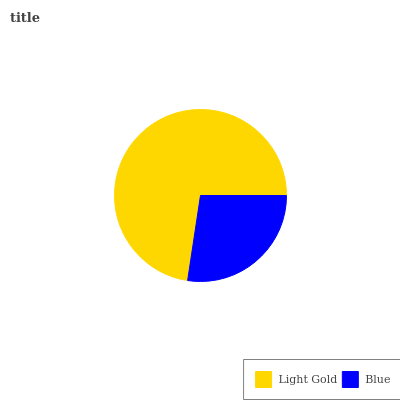Is Blue the minimum?
Answer yes or no. Yes. Is Light Gold the maximum?
Answer yes or no. Yes. Is Blue the maximum?
Answer yes or no. No. Is Light Gold greater than Blue?
Answer yes or no. Yes. Is Blue less than Light Gold?
Answer yes or no. Yes. Is Blue greater than Light Gold?
Answer yes or no. No. Is Light Gold less than Blue?
Answer yes or no. No. Is Light Gold the high median?
Answer yes or no. Yes. Is Blue the low median?
Answer yes or no. Yes. Is Blue the high median?
Answer yes or no. No. Is Light Gold the low median?
Answer yes or no. No. 